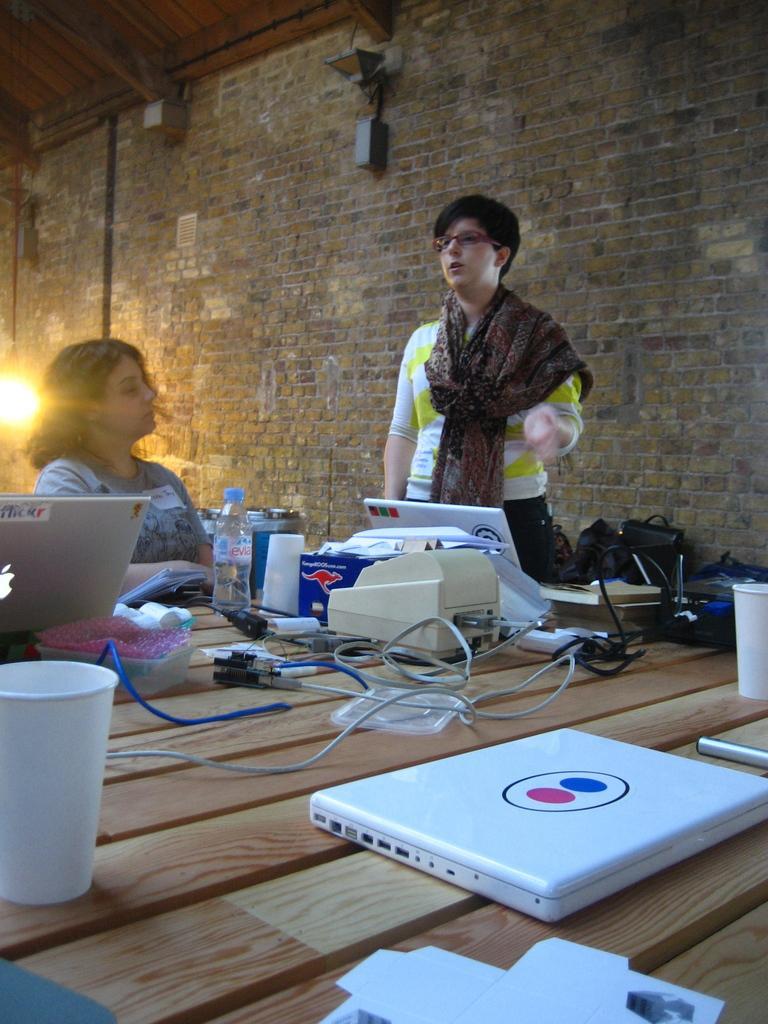Can you describe this image briefly? This person standing. This person sitting. we can see table. On the table we can see laptop,cable,bottle,things. On the background we can see wall. 